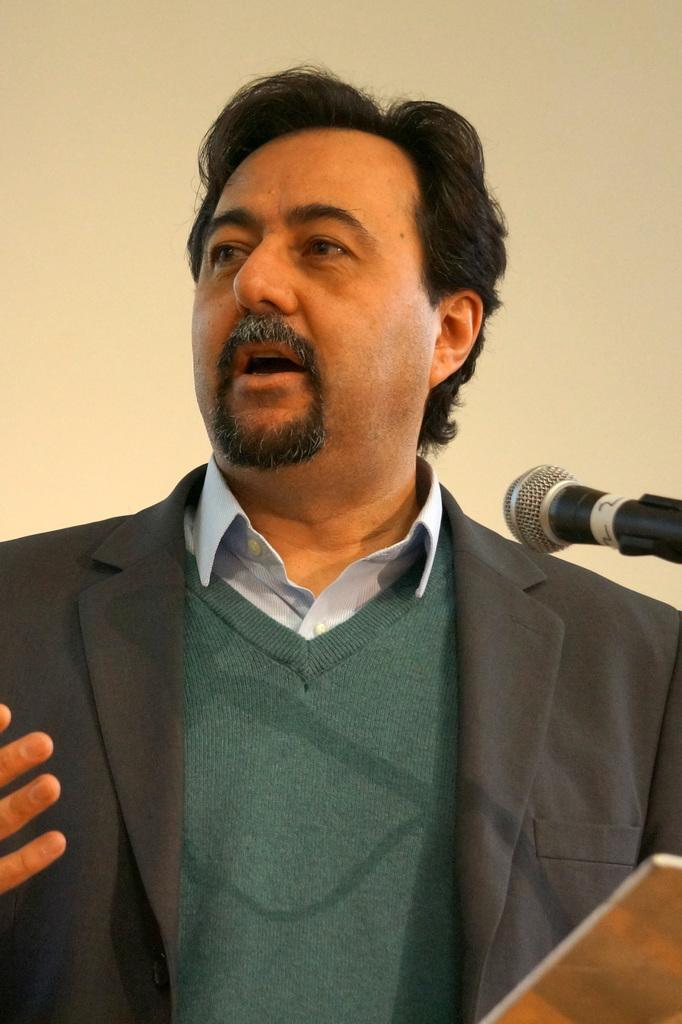What is the main subject of the image? There is a person in the image. What is the person doing in the image? The person is in front of a mic. Can you describe the person's attire? The person is wearing a blazer, a t-shirt, and a colorful shirt. What can be seen in the background of the image? There is a wall in the background of the image. What type of base is supporting the person in the image? There is no base supporting the person in the image; the person is standing on the ground. What kind of boot is visible on the person's foot in the image? There is no boot visible on the person's foot in the image; the person is wearing a blazer, a t-shirt, and a colorful shirt. 